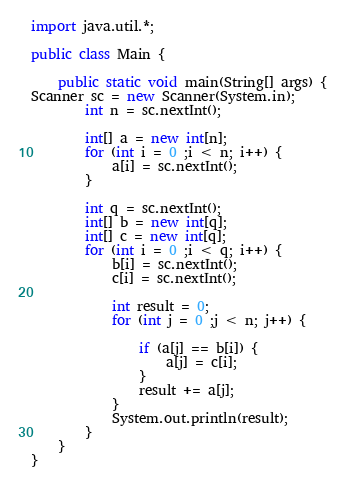Convert code to text. <code><loc_0><loc_0><loc_500><loc_500><_Java_>import java.util.*;

public class Main {

    public static void main(String[] args) {
Scanner sc = new Scanner(System.in);
        int n = sc.nextInt();

        int[] a = new int[n];
        for (int i = 0 ;i < n; i++) {
            a[i] = sc.nextInt();
        }

        int q = sc.nextInt();
        int[] b = new int[q];
        int[] c = new int[q];
        for (int i = 0 ;i < q; i++) {
            b[i] = sc.nextInt();
            c[i] = sc.nextInt();

            int result = 0;
            for (int j = 0 ;j < n; j++) {

                if (a[j] == b[i]) {
                    a[j] = c[i];
                }
                result += a[j];
            }
            System.out.println(result);
        }
    }
}
</code> 